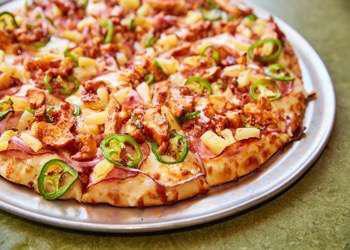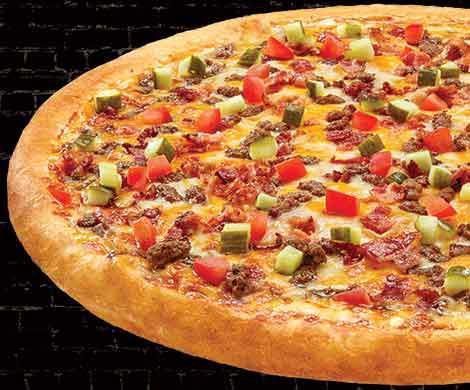The first image is the image on the left, the second image is the image on the right. Considering the images on both sides, is "One image has melted cheese stretched out between two pieces of food, and the other has a whole pizza." valid? Answer yes or no. No. The first image is the image on the left, the second image is the image on the right. For the images displayed, is the sentence "There is a total of two circle pizzas." factually correct? Answer yes or no. Yes. 